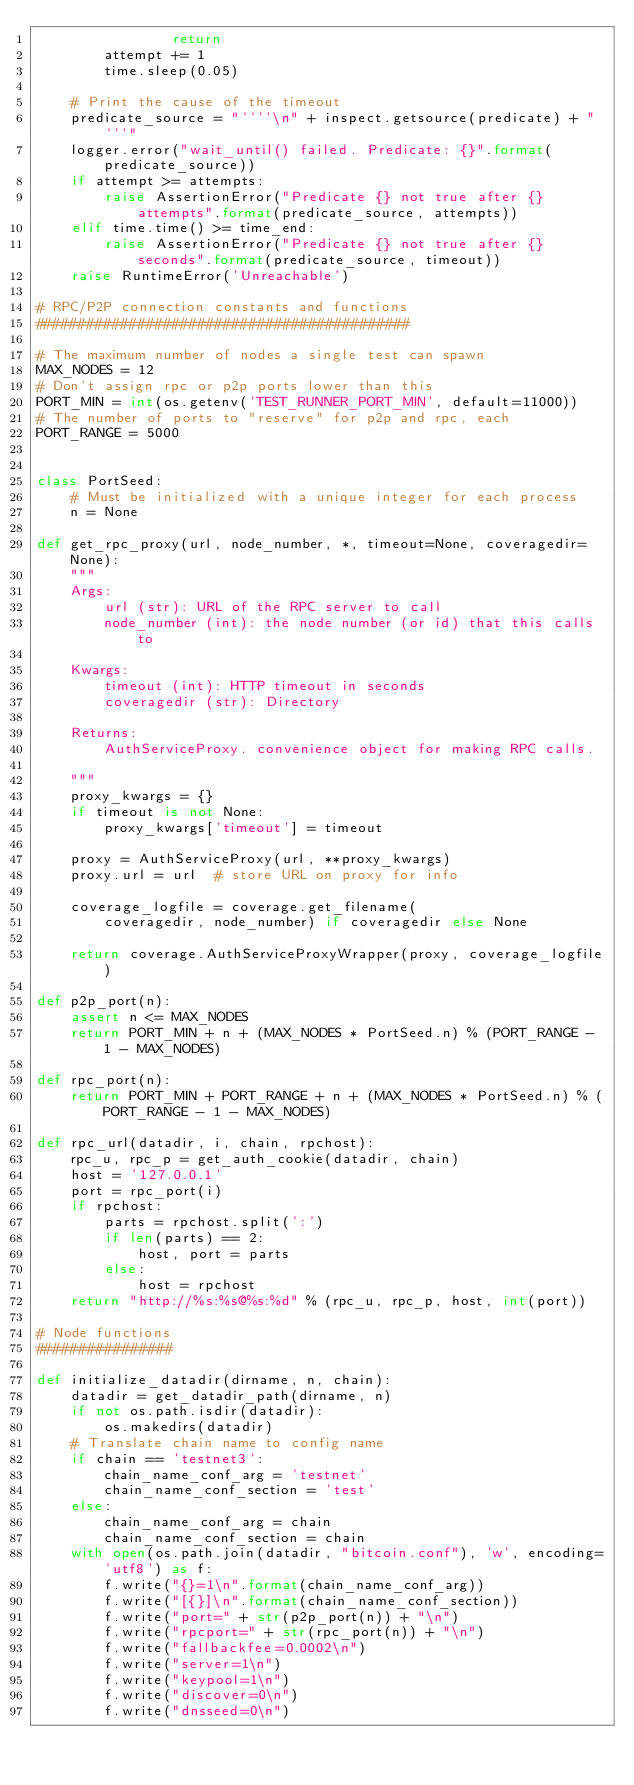<code> <loc_0><loc_0><loc_500><loc_500><_Python_>                return
        attempt += 1
        time.sleep(0.05)

    # Print the cause of the timeout
    predicate_source = "''''\n" + inspect.getsource(predicate) + "'''"
    logger.error("wait_until() failed. Predicate: {}".format(predicate_source))
    if attempt >= attempts:
        raise AssertionError("Predicate {} not true after {} attempts".format(predicate_source, attempts))
    elif time.time() >= time_end:
        raise AssertionError("Predicate {} not true after {} seconds".format(predicate_source, timeout))
    raise RuntimeError('Unreachable')

# RPC/P2P connection constants and functions
############################################

# The maximum number of nodes a single test can spawn
MAX_NODES = 12
# Don't assign rpc or p2p ports lower than this
PORT_MIN = int(os.getenv('TEST_RUNNER_PORT_MIN', default=11000))
# The number of ports to "reserve" for p2p and rpc, each
PORT_RANGE = 5000


class PortSeed:
    # Must be initialized with a unique integer for each process
    n = None

def get_rpc_proxy(url, node_number, *, timeout=None, coveragedir=None):
    """
    Args:
        url (str): URL of the RPC server to call
        node_number (int): the node number (or id) that this calls to

    Kwargs:
        timeout (int): HTTP timeout in seconds
        coveragedir (str): Directory

    Returns:
        AuthServiceProxy. convenience object for making RPC calls.

    """
    proxy_kwargs = {}
    if timeout is not None:
        proxy_kwargs['timeout'] = timeout

    proxy = AuthServiceProxy(url, **proxy_kwargs)
    proxy.url = url  # store URL on proxy for info

    coverage_logfile = coverage.get_filename(
        coveragedir, node_number) if coveragedir else None

    return coverage.AuthServiceProxyWrapper(proxy, coverage_logfile)

def p2p_port(n):
    assert n <= MAX_NODES
    return PORT_MIN + n + (MAX_NODES * PortSeed.n) % (PORT_RANGE - 1 - MAX_NODES)

def rpc_port(n):
    return PORT_MIN + PORT_RANGE + n + (MAX_NODES * PortSeed.n) % (PORT_RANGE - 1 - MAX_NODES)

def rpc_url(datadir, i, chain, rpchost):
    rpc_u, rpc_p = get_auth_cookie(datadir, chain)
    host = '127.0.0.1'
    port = rpc_port(i)
    if rpchost:
        parts = rpchost.split(':')
        if len(parts) == 2:
            host, port = parts
        else:
            host = rpchost
    return "http://%s:%s@%s:%d" % (rpc_u, rpc_p, host, int(port))

# Node functions
################

def initialize_datadir(dirname, n, chain):
    datadir = get_datadir_path(dirname, n)
    if not os.path.isdir(datadir):
        os.makedirs(datadir)
    # Translate chain name to config name
    if chain == 'testnet3':
        chain_name_conf_arg = 'testnet'
        chain_name_conf_section = 'test'
    else:
        chain_name_conf_arg = chain
        chain_name_conf_section = chain
    with open(os.path.join(datadir, "bitcoin.conf"), 'w', encoding='utf8') as f:
        f.write("{}=1\n".format(chain_name_conf_arg))
        f.write("[{}]\n".format(chain_name_conf_section))
        f.write("port=" + str(p2p_port(n)) + "\n")
        f.write("rpcport=" + str(rpc_port(n)) + "\n")
        f.write("fallbackfee=0.0002\n")
        f.write("server=1\n")
        f.write("keypool=1\n")
        f.write("discover=0\n")
        f.write("dnsseed=0\n")</code> 